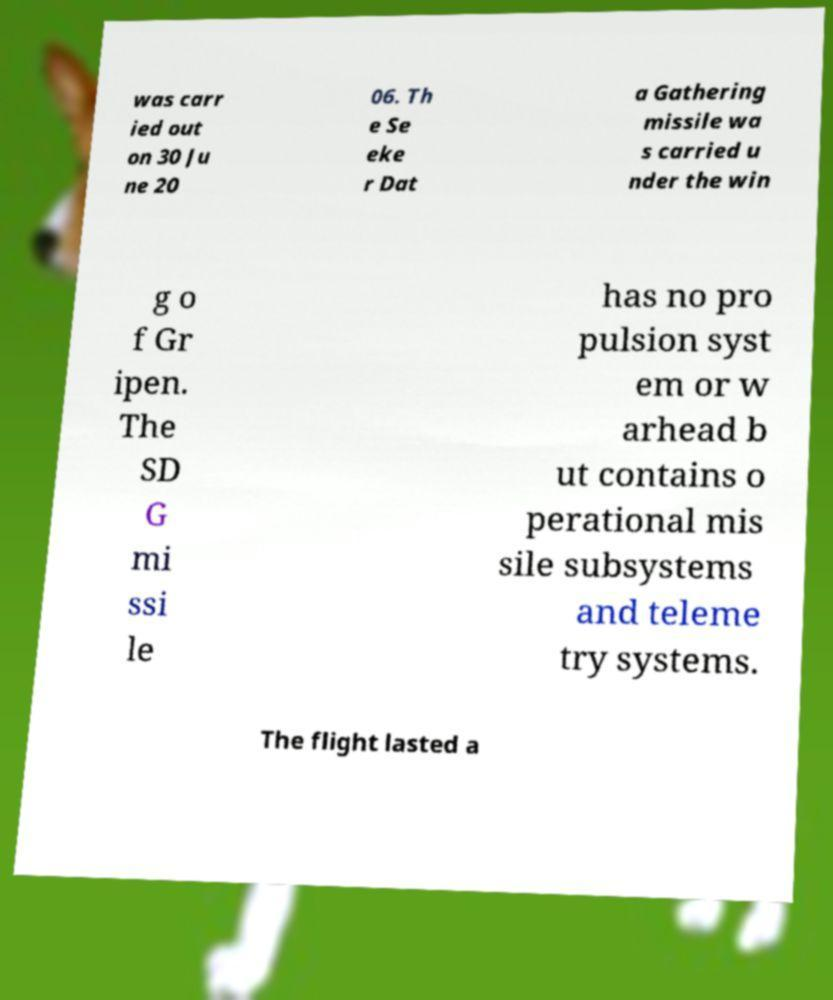What messages or text are displayed in this image? I need them in a readable, typed format. was carr ied out on 30 Ju ne 20 06. Th e Se eke r Dat a Gathering missile wa s carried u nder the win g o f Gr ipen. The SD G mi ssi le has no pro pulsion syst em or w arhead b ut contains o perational mis sile subsystems and teleme try systems. The flight lasted a 